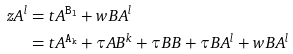Convert formula to latex. <formula><loc_0><loc_0><loc_500><loc_500>z _ { \tt } { A } ^ { l } & = t _ { \tt } { A } ^ { \tt { B } _ { l } } + w _ { \tt } { B A } ^ { l } \\ & = t _ { \tt } { A } ^ { \tt { A } _ { k } } + \tau _ { \tt } { A B } ^ { k } + \tau _ { \tt } { B B } + \tau _ { \tt } { B A } ^ { l } + w _ { \tt } { B A } ^ { l }</formula> 